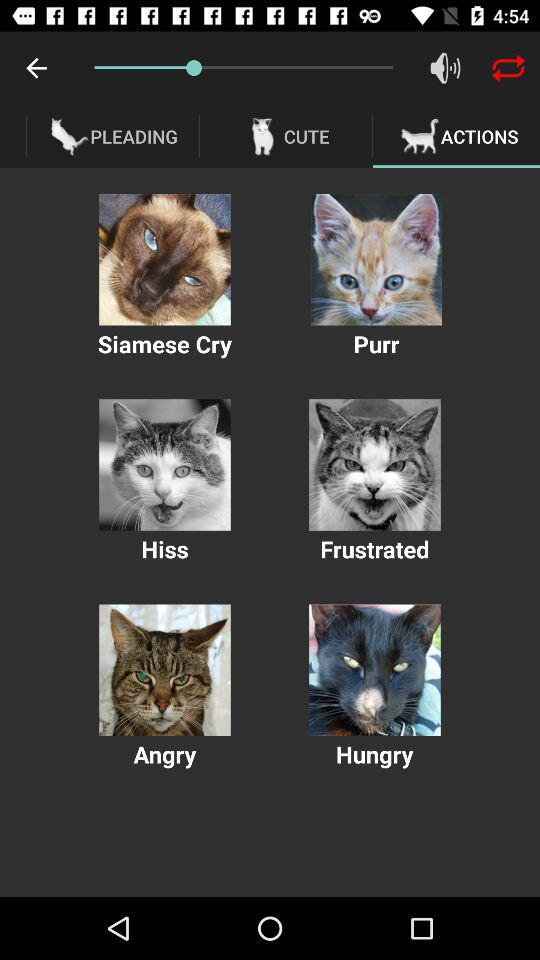Which tab is selected? The selected tab is "ACTIONS". 